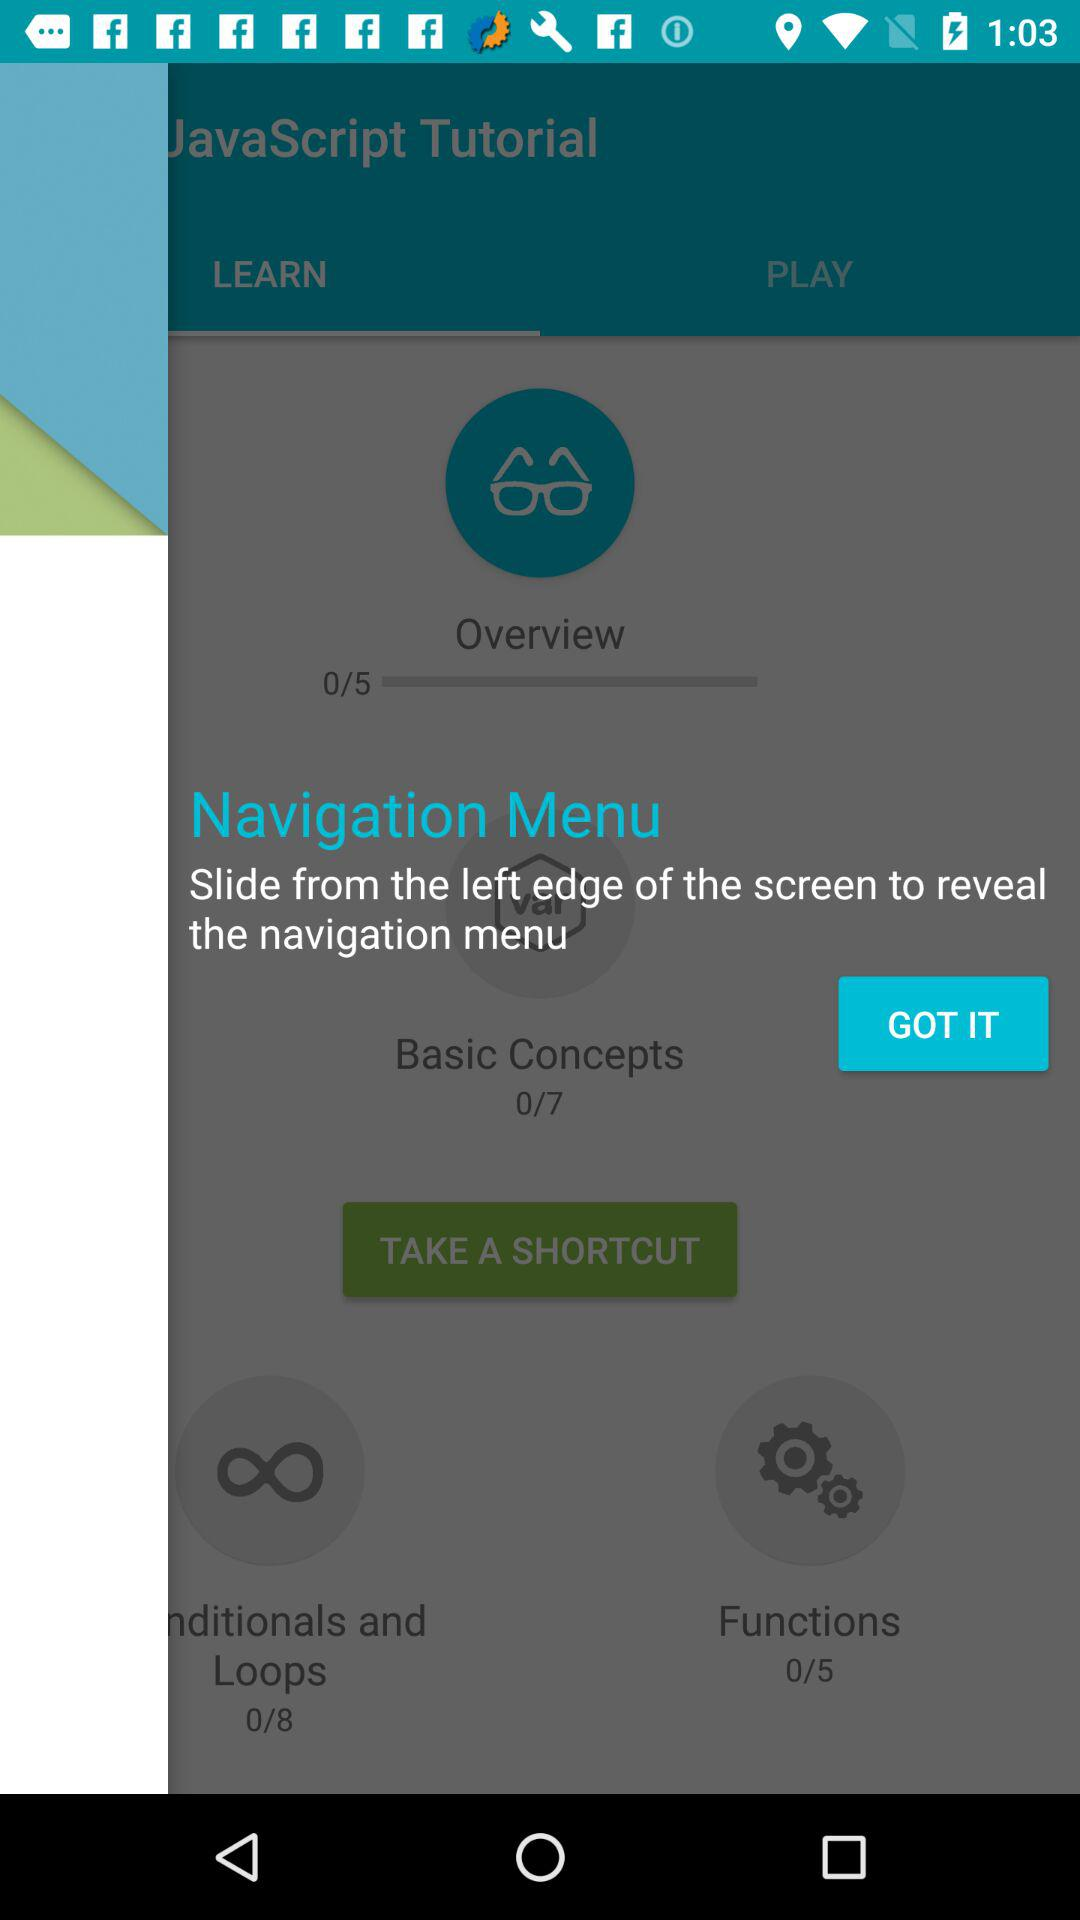Which tab is selected? The selected tab is "LEARN". 